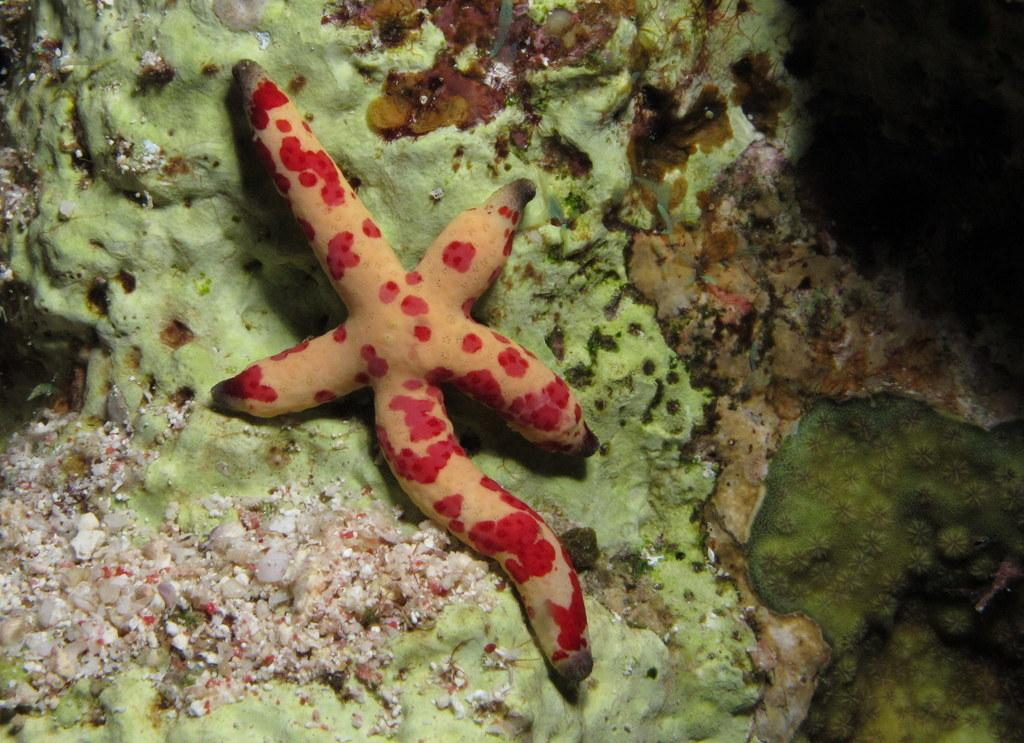What type of marine animal is in the image? There is a starfish in the image. What is the starfish resting on? The starfish is on algae. What committee is the starfish a part of in the image? There is no committee present in the image, as it features a starfish on algae. 